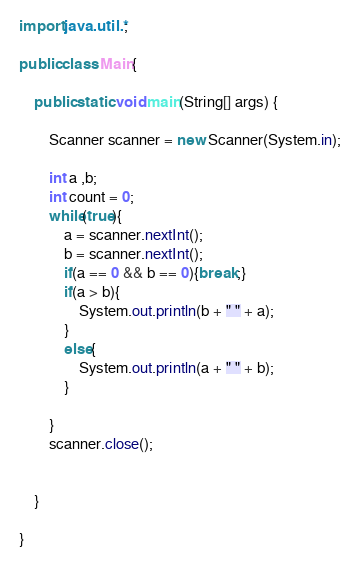Convert code to text. <code><loc_0><loc_0><loc_500><loc_500><_Java_>import java.util.*;

public class Main{

	public static void main(String[] args) {

		Scanner scanner = new Scanner(System.in);
		
		int a ,b;
		int count = 0;
		while(true){
			a = scanner.nextInt();
			b = scanner.nextInt();
			if(a == 0 && b == 0){break;}
			if(a > b){
				System.out.println(b + " " + a);
			}
			else{
				System.out.println(a + " " + b);
			}
				
		}
		scanner.close();
		
		
	}

}</code> 